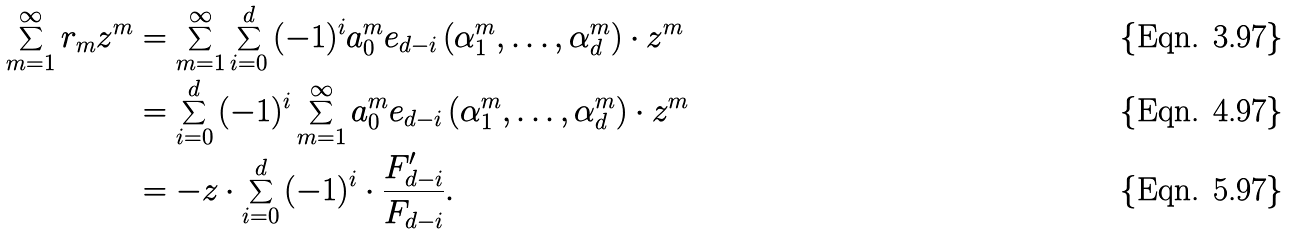<formula> <loc_0><loc_0><loc_500><loc_500>\sum _ { m = 1 } ^ { \infty } { r _ { m } z ^ { m } } & = \sum _ { m = 1 } ^ { \infty } { \sum _ { i = 0 } ^ { d } { ( - 1 ) ^ { i } a _ { 0 } ^ { m } e _ { d - i } \left ( { \alpha _ { 1 } ^ { m } , \dots , \alpha _ { d } ^ { m } } \right ) } \cdot z ^ { m } } \\ & = \sum _ { i = 0 } ^ { d } { ( - 1 ) ^ { i } \sum _ { m = 1 } ^ { \infty } { a _ { 0 } ^ { m } e _ { d - i } \left ( { \alpha _ { 1 } ^ { m } , \dots , \alpha _ { d } ^ { m } } \right ) } \cdot z ^ { m } } \\ & = - z \cdot \sum _ { i = 0 } ^ { d } { ( - 1 ) ^ { i } \cdot \frac { { F _ { d - i } ^ { \prime } } } { { F _ { d - i } } } } .</formula> 